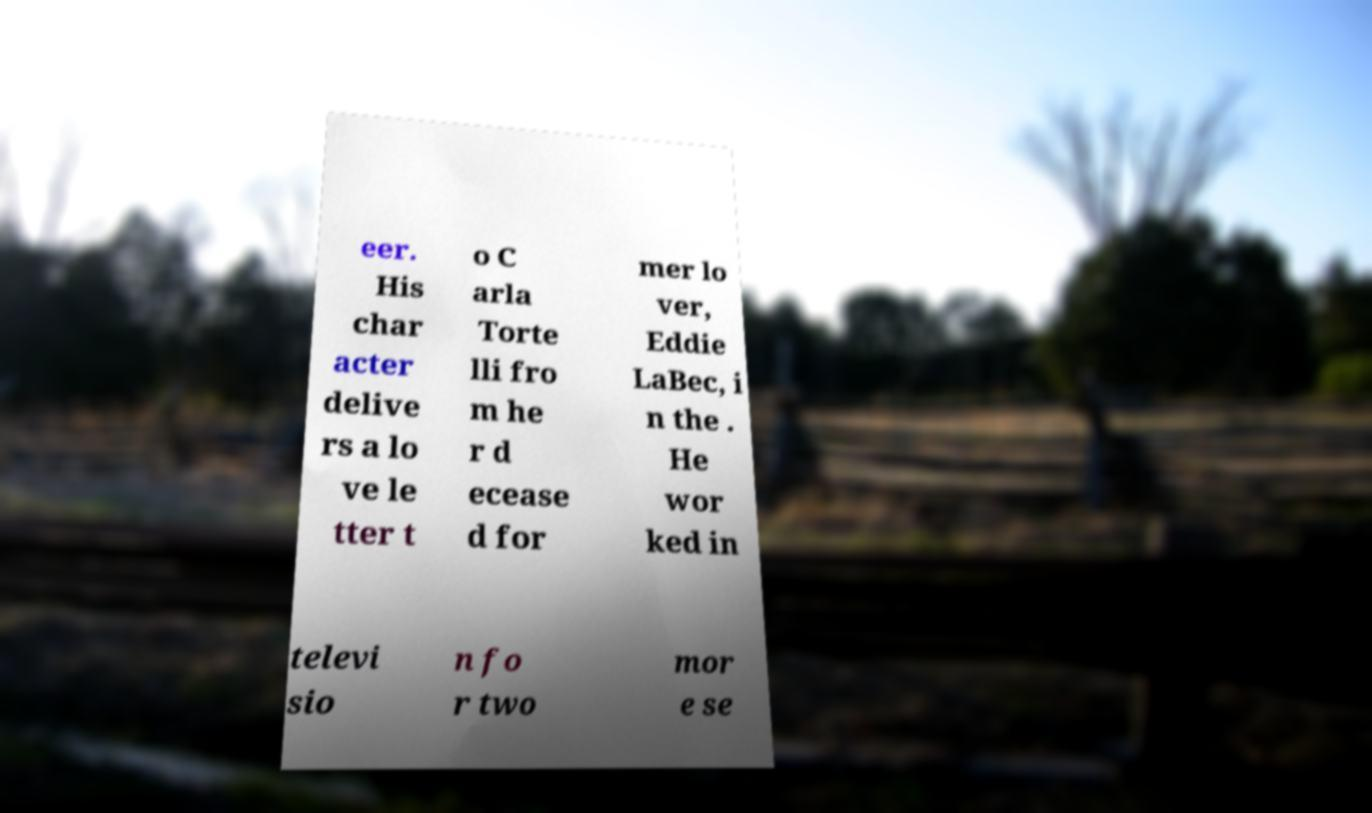Please identify and transcribe the text found in this image. eer. His char acter delive rs a lo ve le tter t o C arla Torte lli fro m he r d ecease d for mer lo ver, Eddie LaBec, i n the . He wor ked in televi sio n fo r two mor e se 